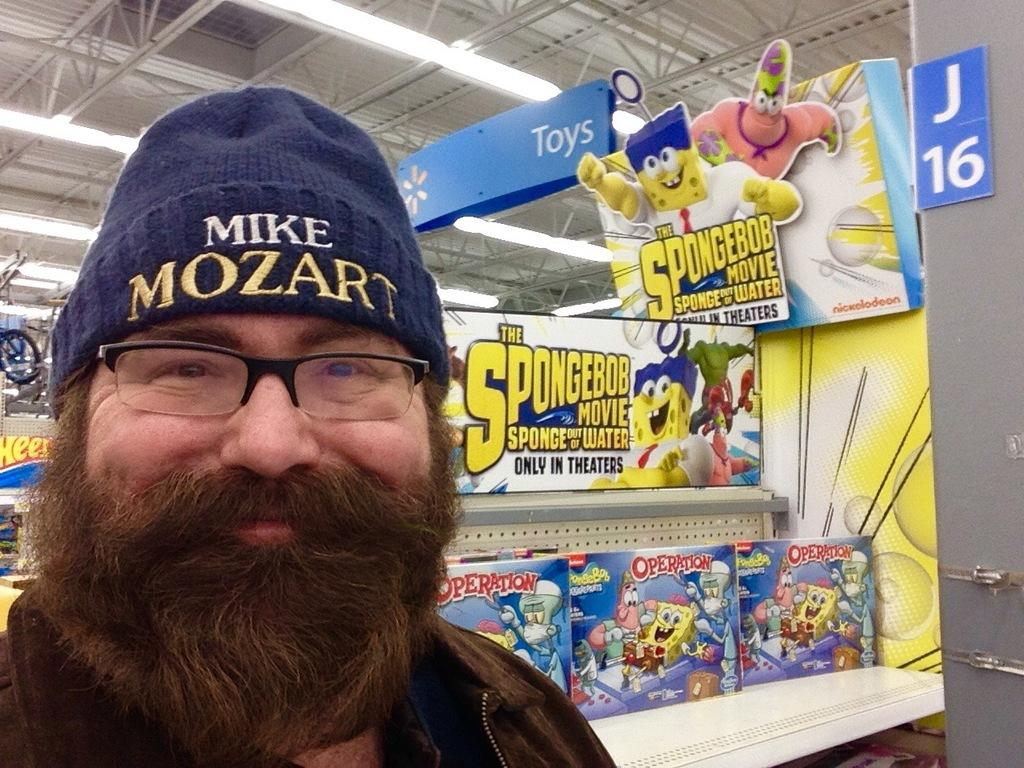Who is present in the image? There is a man in the image. What is the man doing in the image? The man is standing and smiling. What can be seen behind the man in the image? There are toys in a rack behind the man. What is the structure of the image? The image has a roof at the top. What can be seen at the top of the image? There are lights visible at the top of the image. What type of knife is the man using to cut the fairies in the image? There is no knife or fairies present in the image. How many boats are visible in the image? There are no boats visible in the image. 